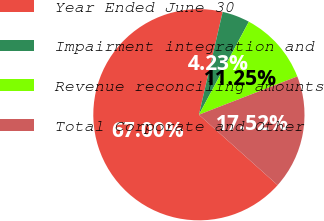Convert chart to OTSL. <chart><loc_0><loc_0><loc_500><loc_500><pie_chart><fcel>Year Ended June 30<fcel>Impairment integration and<fcel>Revenue reconciling amounts<fcel>Total Corporate and Other<nl><fcel>67.01%<fcel>4.23%<fcel>11.25%<fcel>17.52%<nl></chart> 